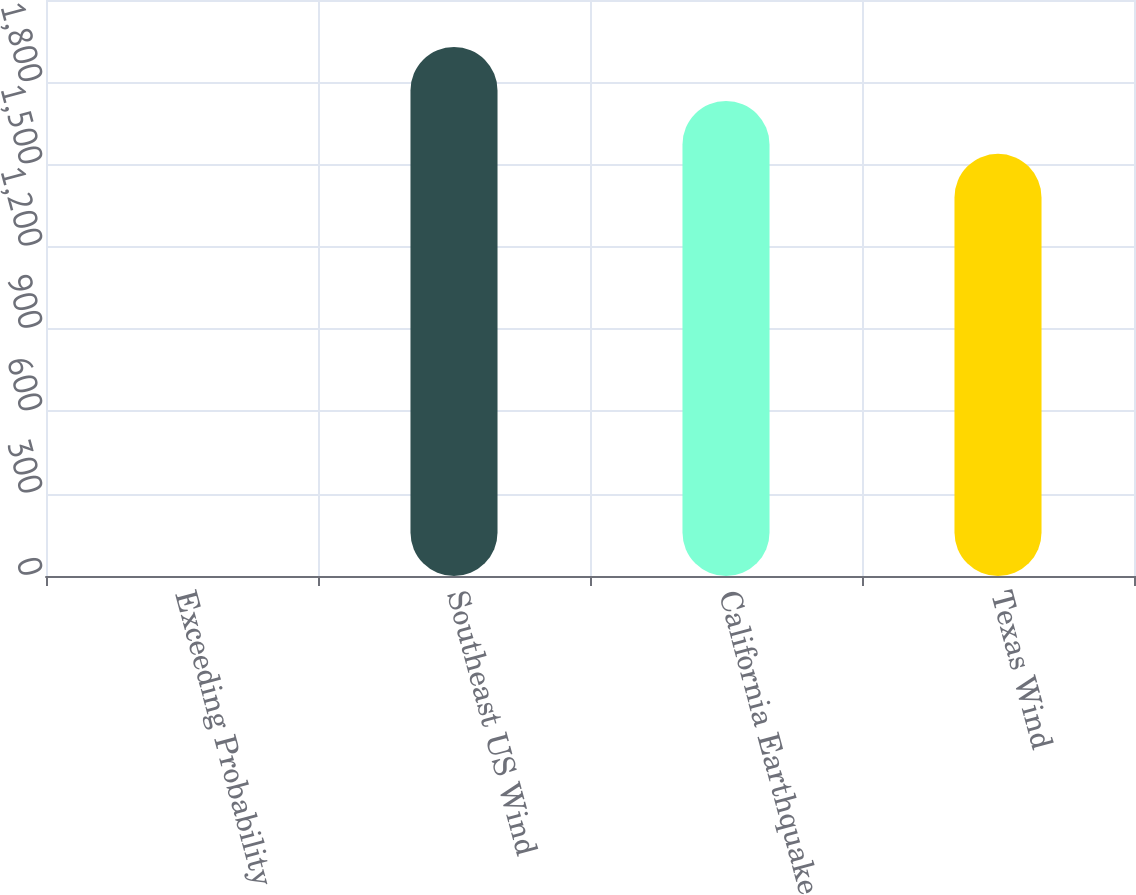Convert chart to OTSL. <chart><loc_0><loc_0><loc_500><loc_500><bar_chart><fcel>Exceeding Probability<fcel>Southeast US Wind<fcel>California Earthquake<fcel>Texas Wind<nl><fcel>0.4<fcel>1929<fcel>1731.86<fcel>1539<nl></chart> 